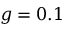Convert formula to latex. <formula><loc_0><loc_0><loc_500><loc_500>g = 0 . 1</formula> 